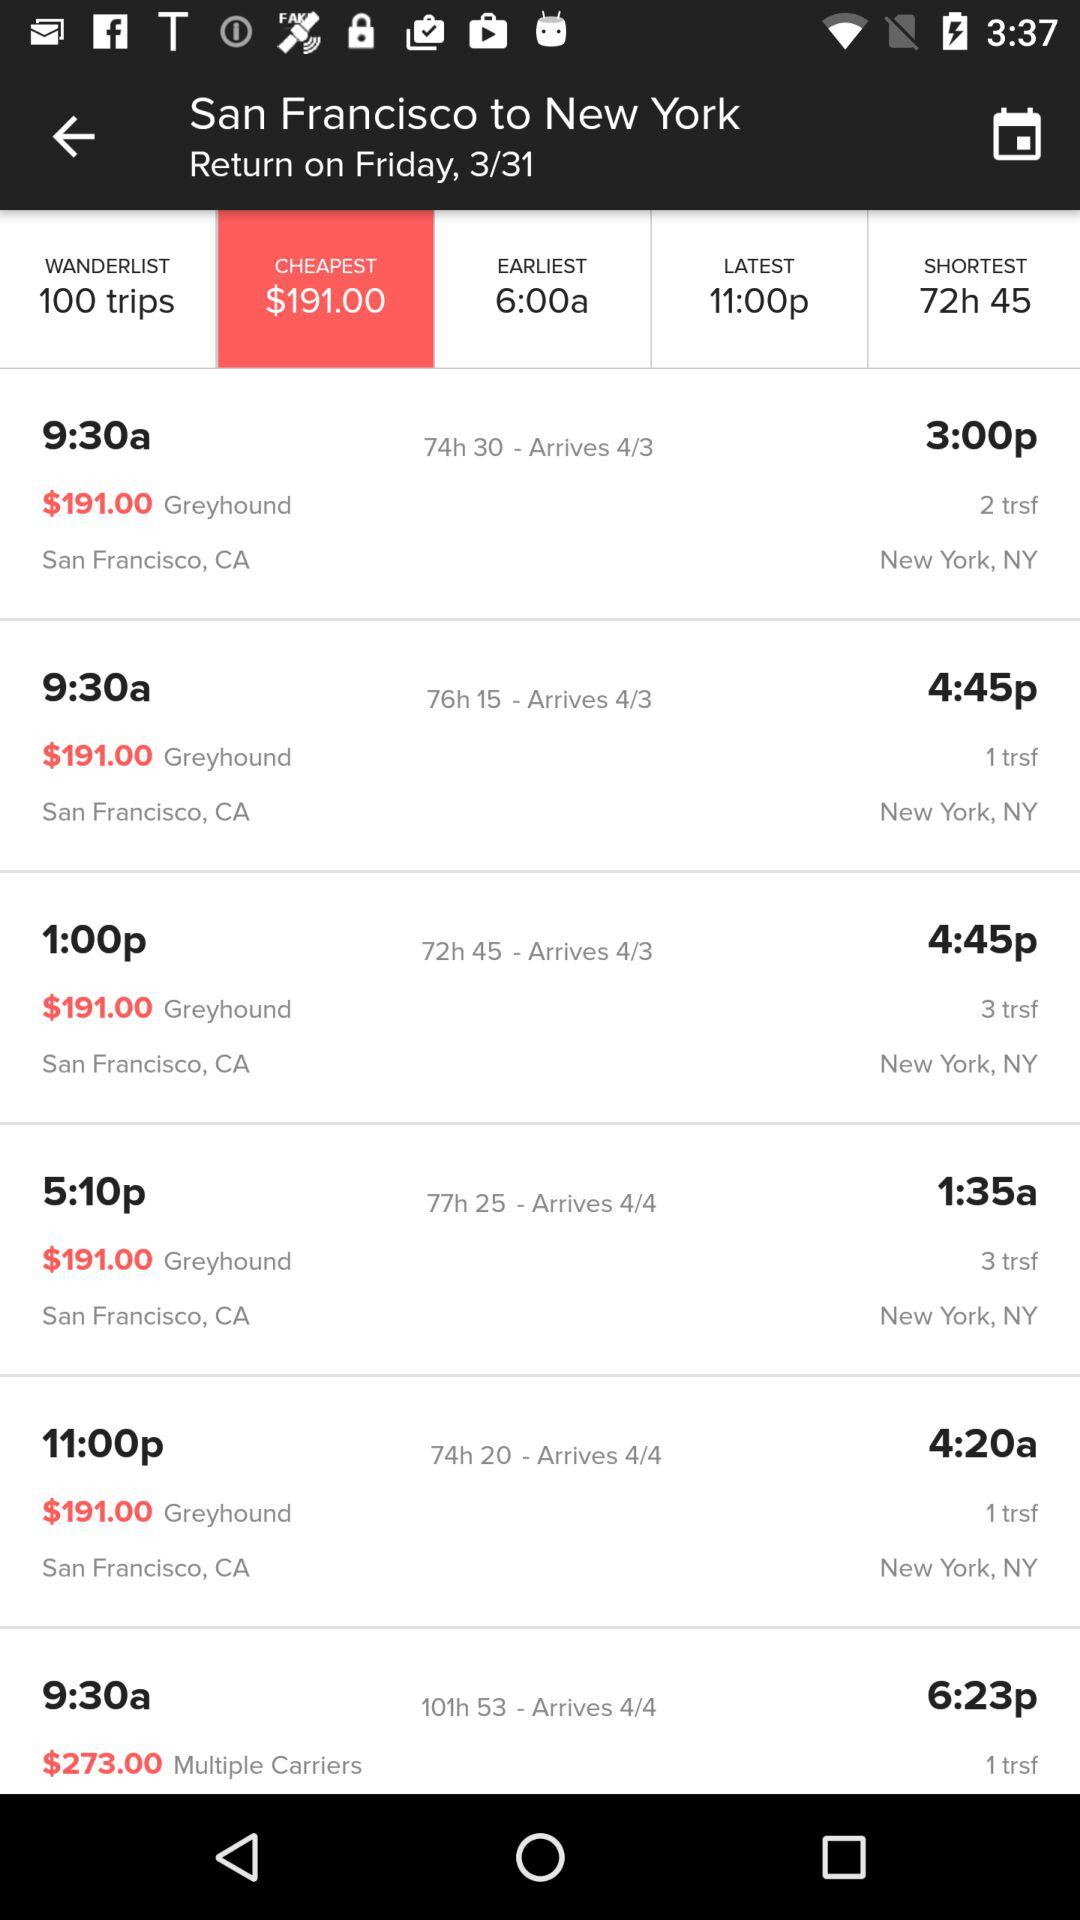What is the earliest time to reach the destination? The earliest time is 6:00 am. 